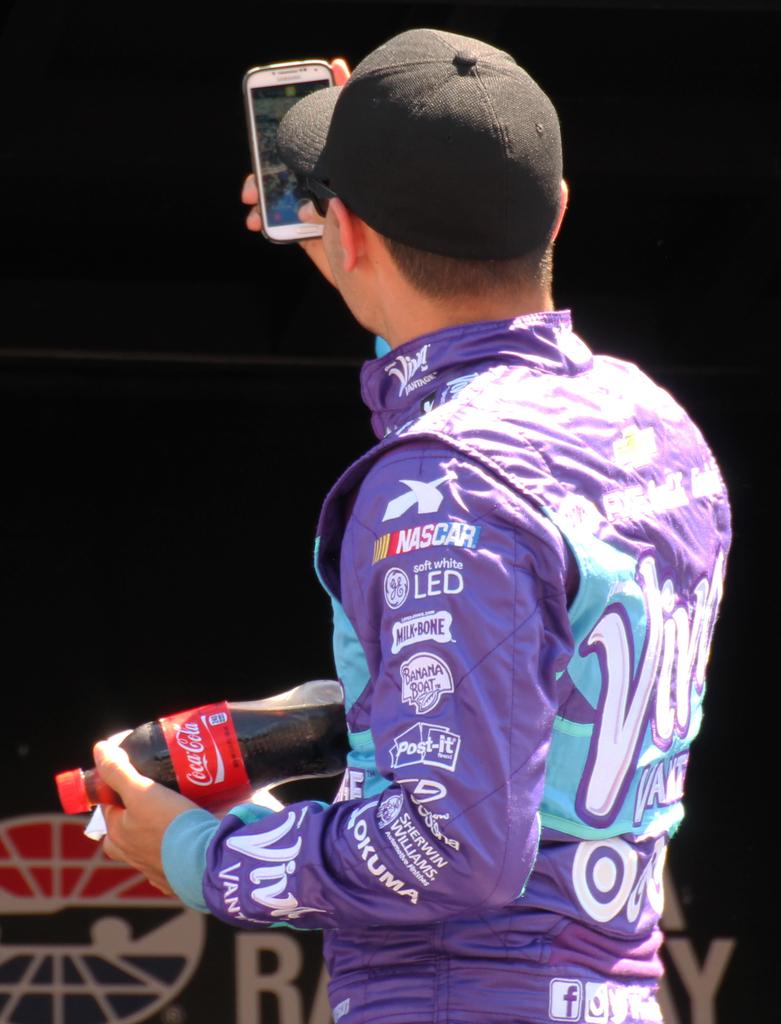What type of racecar driver is this?
Provide a succinct answer. Nascar. Is banana boat one of his sponsors?
Offer a terse response. Yes. 